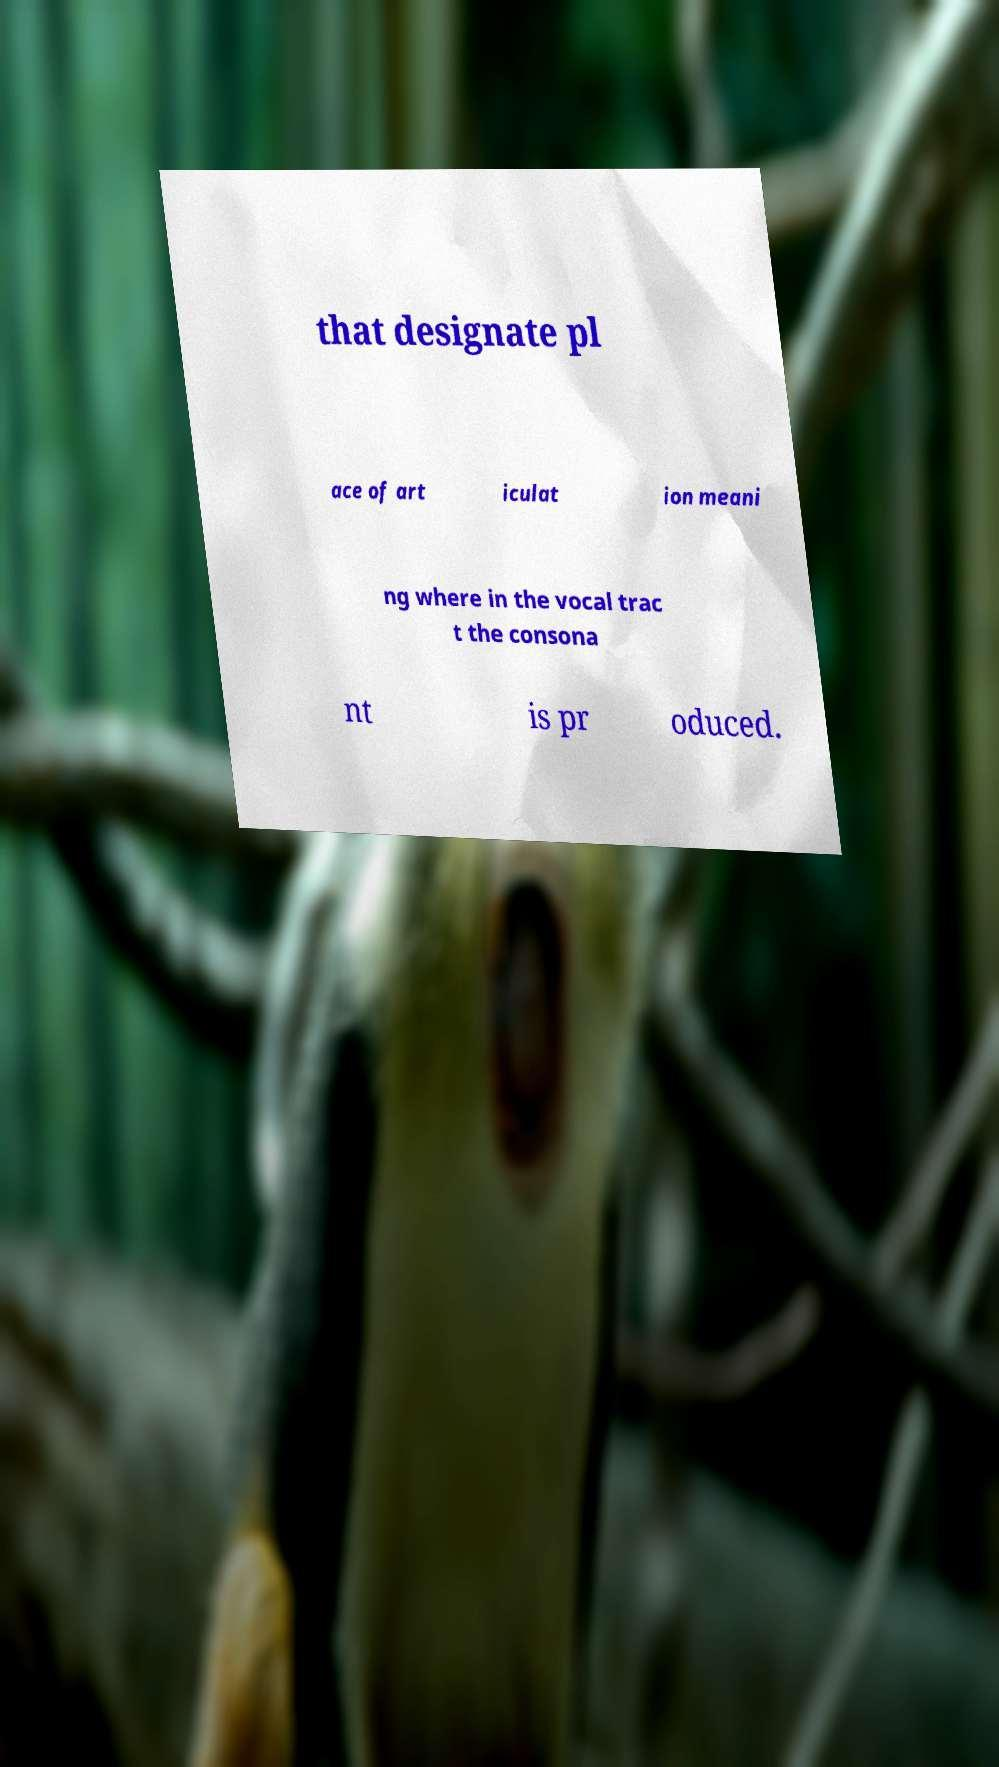Can you accurately transcribe the text from the provided image for me? that designate pl ace of art iculat ion meani ng where in the vocal trac t the consona nt is pr oduced. 